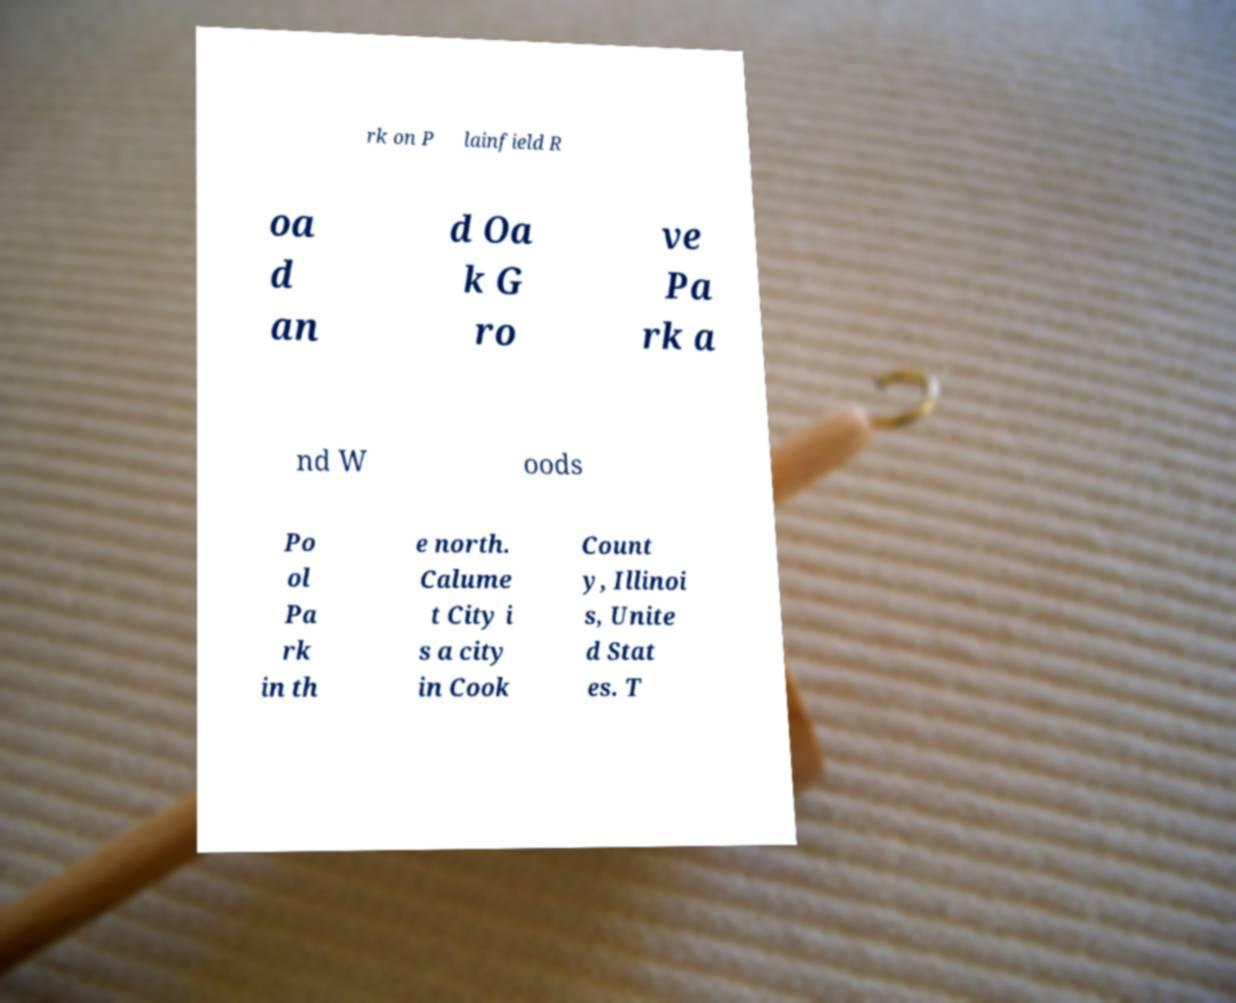Please read and relay the text visible in this image. What does it say? rk on P lainfield R oa d an d Oa k G ro ve Pa rk a nd W oods Po ol Pa rk in th e north. Calume t City i s a city in Cook Count y, Illinoi s, Unite d Stat es. T 